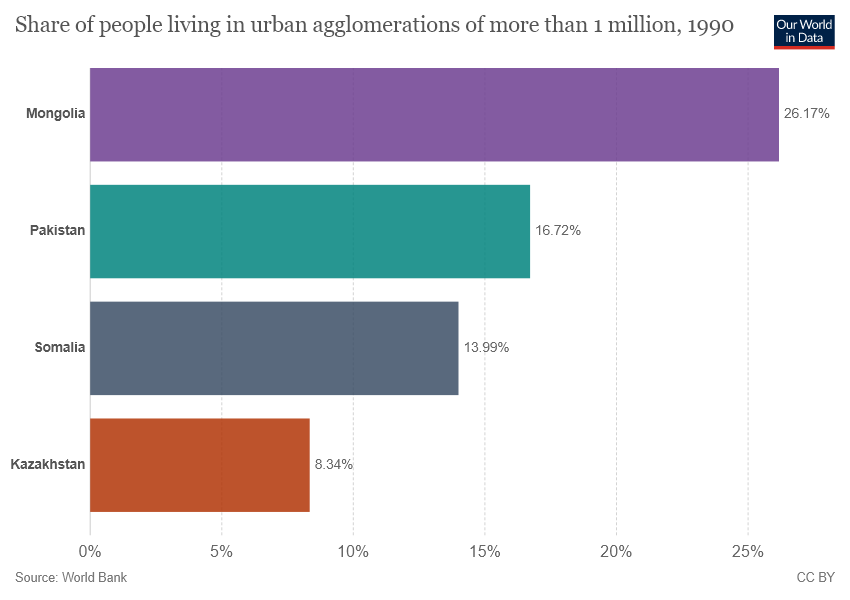Highlight a few significant elements in this photo. The median percentage share of people living in urban agglomerations in Pakistan is 0.552777778... and is higher than the overall share of people in the country. Kazakhstan has the least share of people living in urban agglomerations among all countries. 